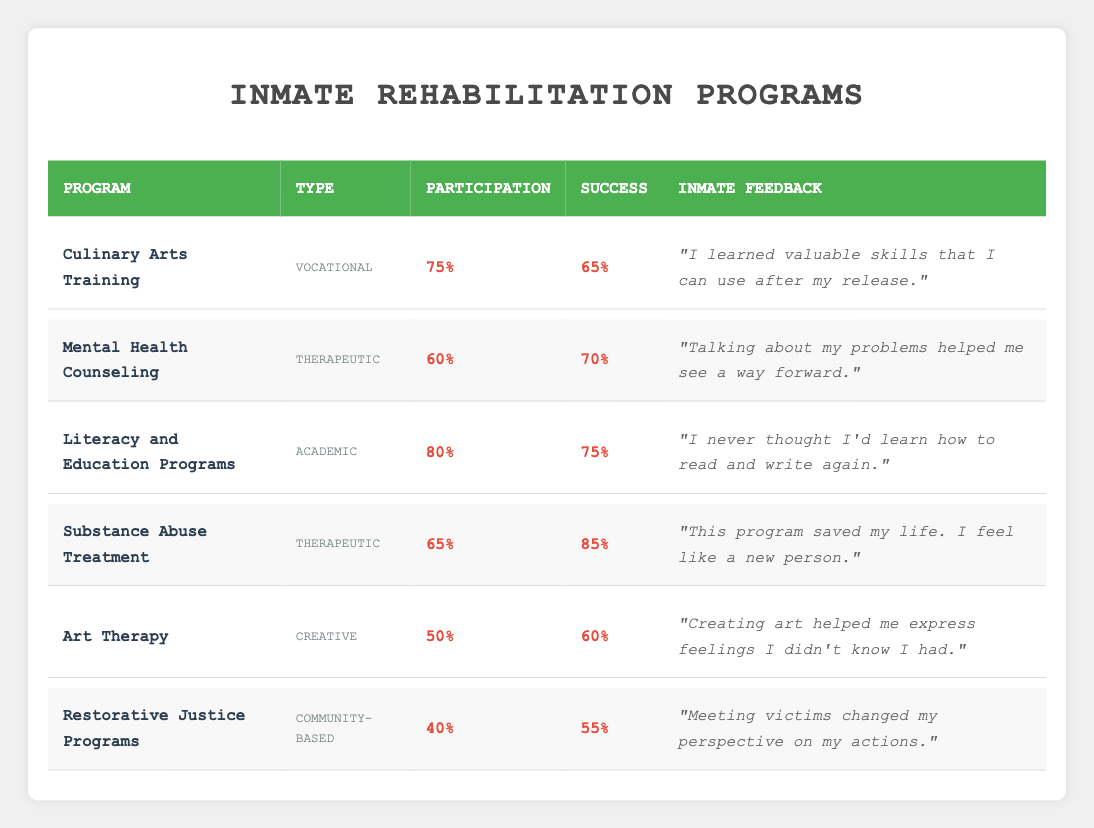What is the success rate of the Substance Abuse Treatment program? The table lists the success rate for the Substance Abuse Treatment program under the "Success" column, showing that it is 85%.
Answer: 85% Which program has the highest participation rate? By reviewing the "Participation" column, the Literacy and Education Programs are noted to have the highest participation rate at 80%.
Answer: 80% What type of program is the Art Therapy? In the table, the type of Art Therapy is identified under the "Type" column, categorized as 'Creative'.
Answer: Creative Is the success rate for the Restorative Justice Programs higher than the participation rate? Looking at the "Success" and "Participation" columns, the success rate for Restorative Justice Programs is 55%, which is lower than the participation rate of 40%. Therefore, the statement is false.
Answer: No Calculate the average success rate of all programs listed. To find the average success rate, sum the success rates (65 + 70 + 75 + 85 + 60 + 55) = 410. There are 6 programs, so the average is 410 / 6 ≈ 68.33.
Answer: 68.33 Which therapeutic program has the highest success rate? Checking the types and success rates for therapeutic programs, the Substance Abuse Treatment program has a success rate of 85%, which is higher than Mental Health Counseling at 70%.
Answer: Substance Abuse Treatment What percentage of inmates participated in the Art Therapy program? The "Participation" column shows that 50% of inmates participated in the Art Therapy program.
Answer: 50% Does the Literacy and Education Program have a higher success rate than the Culinary Arts Training? Upon comparing their success rates, Literacy and Education Programs have a success rate of 75% while Culinary Arts Training has 65%. Since 75% is higher, the answer is yes.
Answer: Yes Find the total number of programs categorized as therapeutic. The table lists two programs under the therapeutic category: Mental Health Counseling and Substance Abuse Treatment. Therefore, the total is 2.
Answer: 2 Identify a piece of inmate feedback from the Culinary Arts Training program. The table contains inmate feedback for the Culinary Arts Training program and one example provided is "I learned valuable skills that I can use after my release."
Answer: "I learned valuable skills that I can use after my release." 